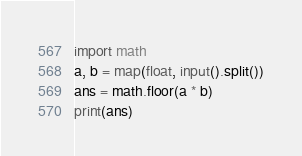<code> <loc_0><loc_0><loc_500><loc_500><_Python_>import math
a, b = map(float, input().split())
ans = math.floor(a * b)
print(ans)
</code> 